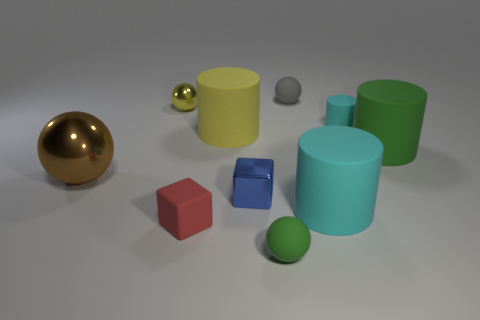Subtract all tiny balls. How many balls are left? 1 Subtract all brown balls. How many balls are left? 3 Subtract all cubes. How many objects are left? 8 Subtract 3 spheres. How many spheres are left? 1 Subtract all purple spheres. Subtract all cyan cubes. How many spheres are left? 4 Subtract all cyan cylinders. How many green blocks are left? 0 Subtract all small rubber cubes. Subtract all large brown balls. How many objects are left? 8 Add 3 yellow metal objects. How many yellow metal objects are left? 4 Add 5 green rubber cylinders. How many green rubber cylinders exist? 6 Subtract 0 cyan balls. How many objects are left? 10 